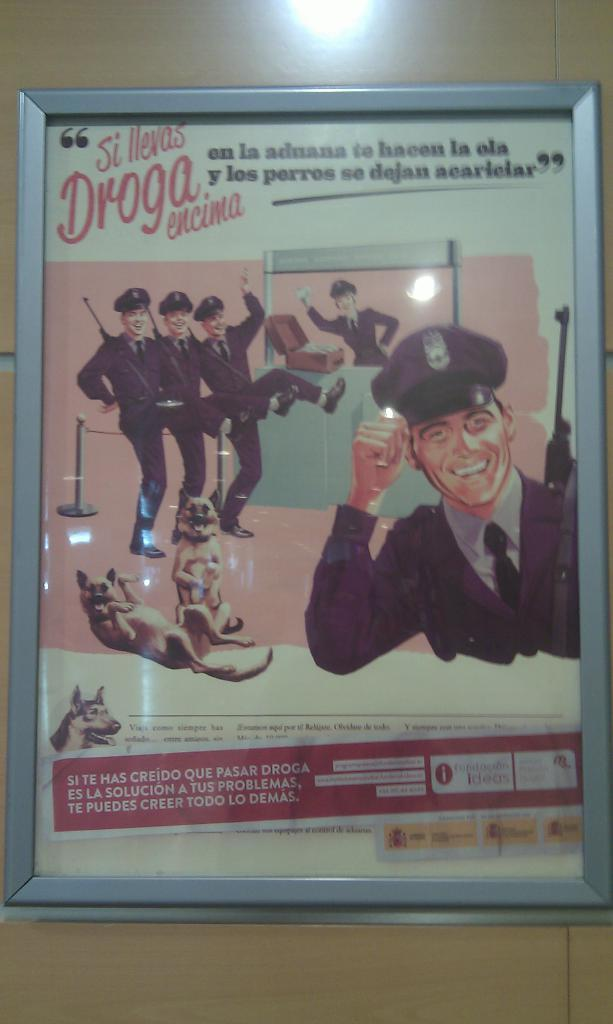What is displayed in a frame in the image? There is a poster in a frame in the image. What type of light is visible at the top of the image? There is a light at the top of the image. What subjects are depicted on the poster? The poster contains images of police officers and dogs. Is there any text on the poster? Yes, there is text on the poster. What is the order of the police officers and dogs on the poster? There is no specific order of the police officers and dogs on the poster; they are depicted in various arrangements. 